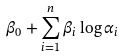Convert formula to latex. <formula><loc_0><loc_0><loc_500><loc_500>\beta _ { 0 } + \sum _ { i = 1 } ^ { n } \beta _ { i } \log \alpha _ { i }</formula> 